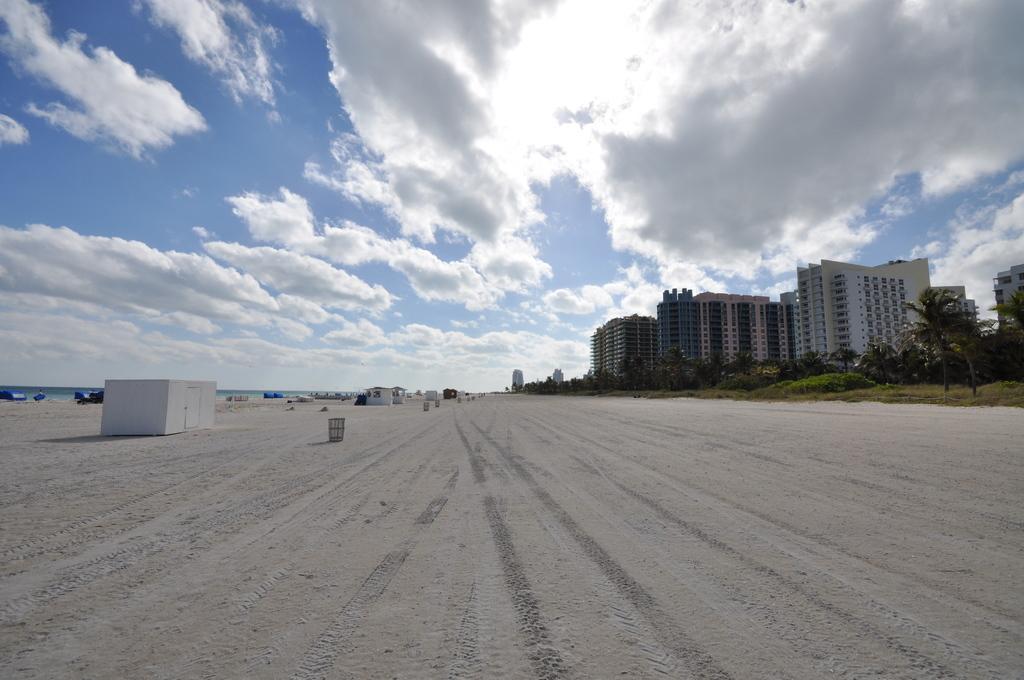Can you describe this image briefly? In this picture we can see sheds and some objects on the ground, buildings, trees, grass and in the background we can see the sky with clouds. 